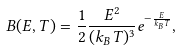Convert formula to latex. <formula><loc_0><loc_0><loc_500><loc_500>B ( E , T ) = \frac { 1 } { 2 } \frac { E ^ { 2 } } { ( k _ { B } T ) ^ { 3 } } e ^ { - \frac { E } { k _ { B } T } } ,</formula> 